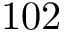Convert formula to latex. <formula><loc_0><loc_0><loc_500><loc_500>1 0 2</formula> 